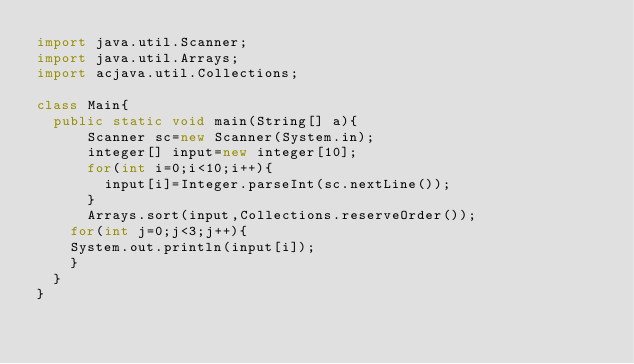<code> <loc_0><loc_0><loc_500><loc_500><_Java_>import java.util.Scanner;
import java.util.Arrays;
import acjava.util.Collections;

class Main{
	public static void main(String[] a){
			Scanner sc=new Scanner(System.in);
			integer[] input=new integer[10];
			for(int i=0;i<10;i++){
				input[i]=Integer.parseInt(sc.nextLine());
			}
			Arrays.sort(input,Collections.reserveOrder());
		for(int j=0;j<3;j++){
		System.out.println(input[i]);
		}
	}
}</code> 